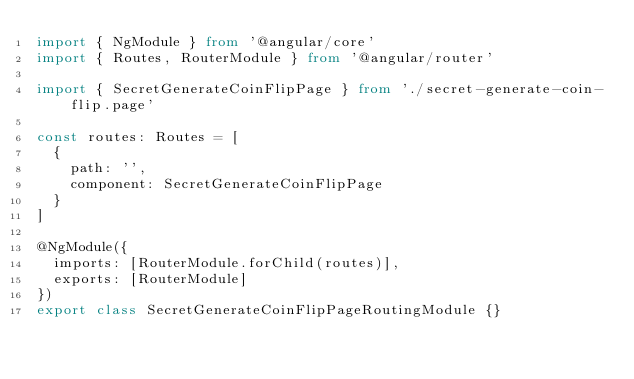<code> <loc_0><loc_0><loc_500><loc_500><_TypeScript_>import { NgModule } from '@angular/core'
import { Routes, RouterModule } from '@angular/router'

import { SecretGenerateCoinFlipPage } from './secret-generate-coin-flip.page'

const routes: Routes = [
  {
    path: '',
    component: SecretGenerateCoinFlipPage
  }
]

@NgModule({
  imports: [RouterModule.forChild(routes)],
  exports: [RouterModule]
})
export class SecretGenerateCoinFlipPageRoutingModule {}
</code> 